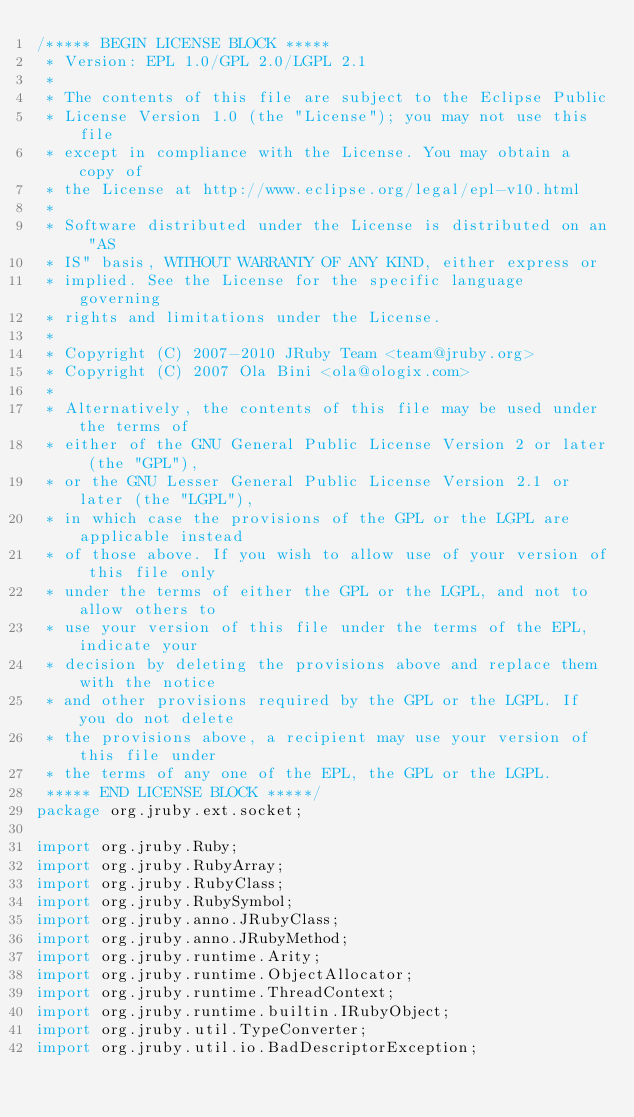Convert code to text. <code><loc_0><loc_0><loc_500><loc_500><_Java_>/***** BEGIN LICENSE BLOCK *****
 * Version: EPL 1.0/GPL 2.0/LGPL 2.1
 *
 * The contents of this file are subject to the Eclipse Public
 * License Version 1.0 (the "License"); you may not use this file
 * except in compliance with the License. You may obtain a copy of
 * the License at http://www.eclipse.org/legal/epl-v10.html
 *
 * Software distributed under the License is distributed on an "AS
 * IS" basis, WITHOUT WARRANTY OF ANY KIND, either express or
 * implied. See the License for the specific language governing
 * rights and limitations under the License.
 *
 * Copyright (C) 2007-2010 JRuby Team <team@jruby.org>
 * Copyright (C) 2007 Ola Bini <ola@ologix.com>
 *
 * Alternatively, the contents of this file may be used under the terms of
 * either of the GNU General Public License Version 2 or later (the "GPL"),
 * or the GNU Lesser General Public License Version 2.1 or later (the "LGPL"),
 * in which case the provisions of the GPL or the LGPL are applicable instead
 * of those above. If you wish to allow use of your version of this file only
 * under the terms of either the GPL or the LGPL, and not to allow others to
 * use your version of this file under the terms of the EPL, indicate your
 * decision by deleting the provisions above and replace them with the notice
 * and other provisions required by the GPL or the LGPL. If you do not delete
 * the provisions above, a recipient may use your version of this file under
 * the terms of any one of the EPL, the GPL or the LGPL.
 ***** END LICENSE BLOCK *****/
package org.jruby.ext.socket;

import org.jruby.Ruby;
import org.jruby.RubyArray;
import org.jruby.RubyClass;
import org.jruby.RubySymbol;
import org.jruby.anno.JRubyClass;
import org.jruby.anno.JRubyMethod;
import org.jruby.runtime.Arity;
import org.jruby.runtime.ObjectAllocator;
import org.jruby.runtime.ThreadContext;
import org.jruby.runtime.builtin.IRubyObject;
import org.jruby.util.TypeConverter;
import org.jruby.util.io.BadDescriptorException;</code> 